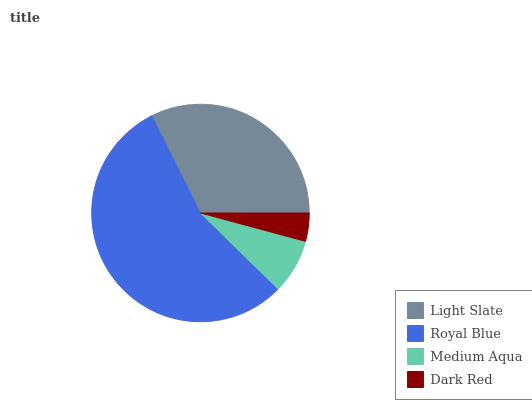Is Dark Red the minimum?
Answer yes or no. Yes. Is Royal Blue the maximum?
Answer yes or no. Yes. Is Medium Aqua the minimum?
Answer yes or no. No. Is Medium Aqua the maximum?
Answer yes or no. No. Is Royal Blue greater than Medium Aqua?
Answer yes or no. Yes. Is Medium Aqua less than Royal Blue?
Answer yes or no. Yes. Is Medium Aqua greater than Royal Blue?
Answer yes or no. No. Is Royal Blue less than Medium Aqua?
Answer yes or no. No. Is Light Slate the high median?
Answer yes or no. Yes. Is Medium Aqua the low median?
Answer yes or no. Yes. Is Royal Blue the high median?
Answer yes or no. No. Is Light Slate the low median?
Answer yes or no. No. 